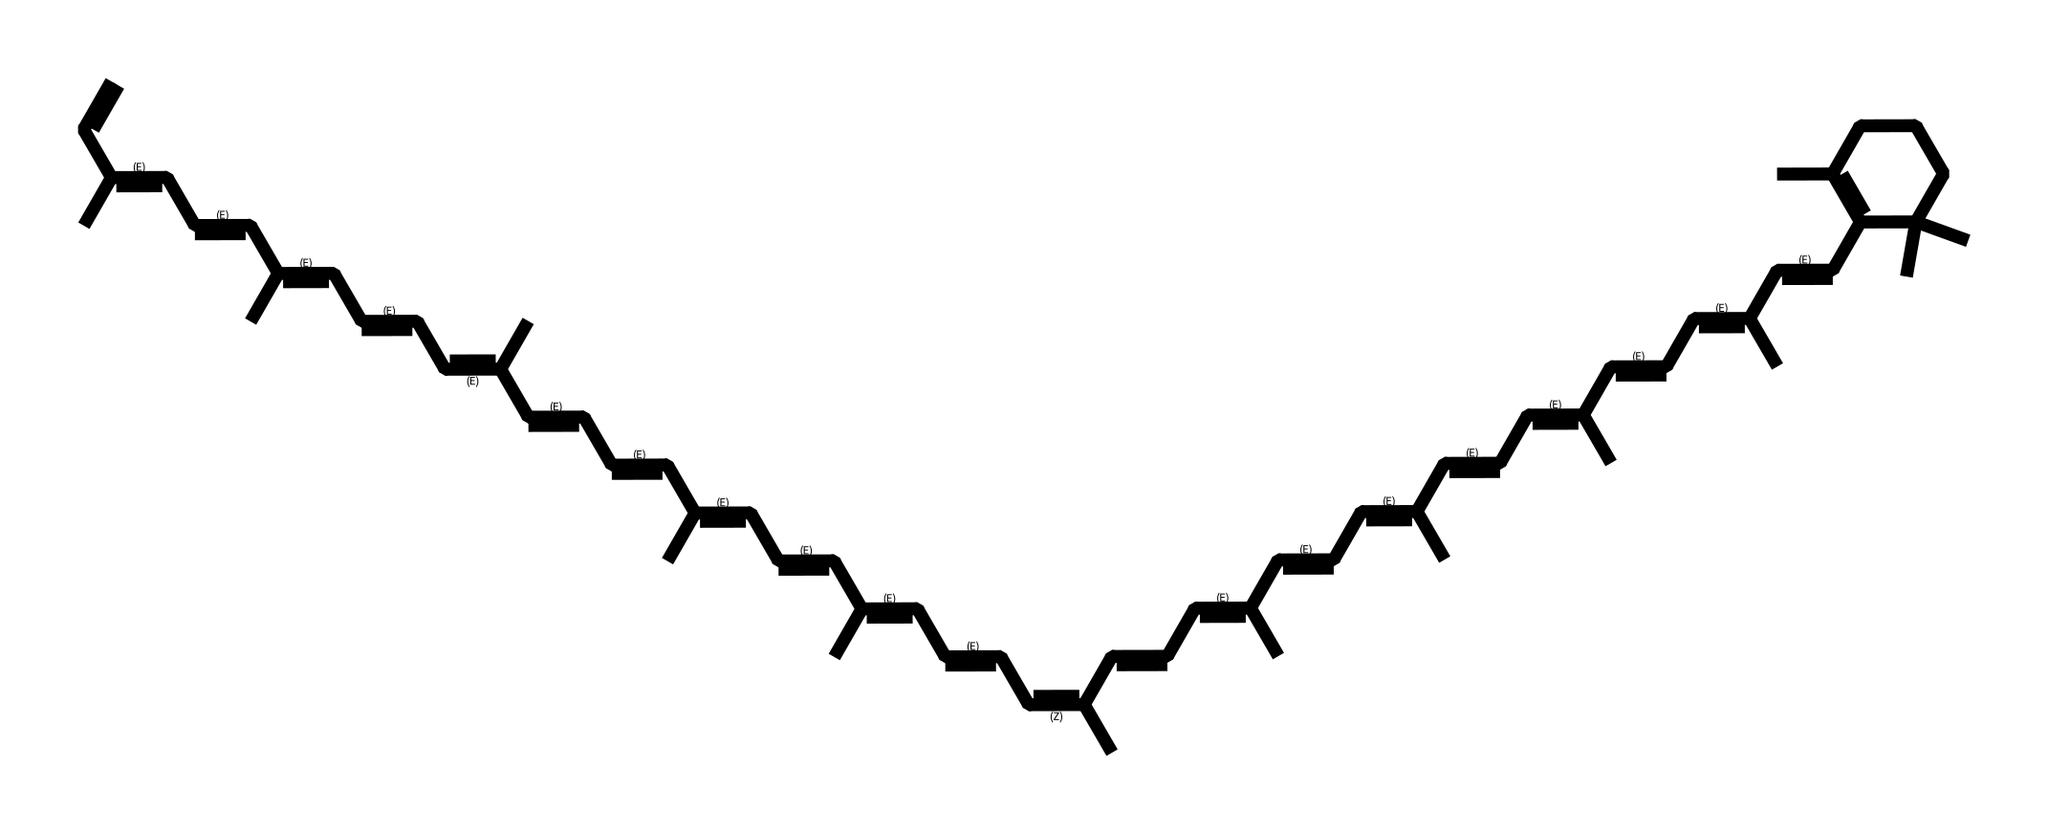What is the name of the compound represented by this SMILES? The SMILES structure represents the compound lycopene, which is a carotenoid known for its antioxidant properties and is predominantly found in tomatoes.
Answer: lycopene How many carbon atoms are present in this structure? By analyzing the SMILES notation, we count the number of carbon atoms, which are notated by the presence of 'C'. This structure contains a total of 40 carbon atoms.
Answer: 40 What type of chemical structure does lycopene represent? Lycopene has a polyene structure characterized by multiple alternating double bonds, which are indicated by the presence of 'C=C' throughout the SMILES.
Answer: polyene How many double bonds are in this chemical structure? To determine the number of double bonds, we look for the occurrences of 'C=C' in the SMILES code. In this case, there are 11 double bonds present.
Answer: 11 Does lycopene have any functional groups? The structure of lycopene does not contain any functional groups such as hydroxyl (-OH) or carboxyl (-COOH), but instead consists of hydrocarbon chains with multiple double bonds.
Answer: no 